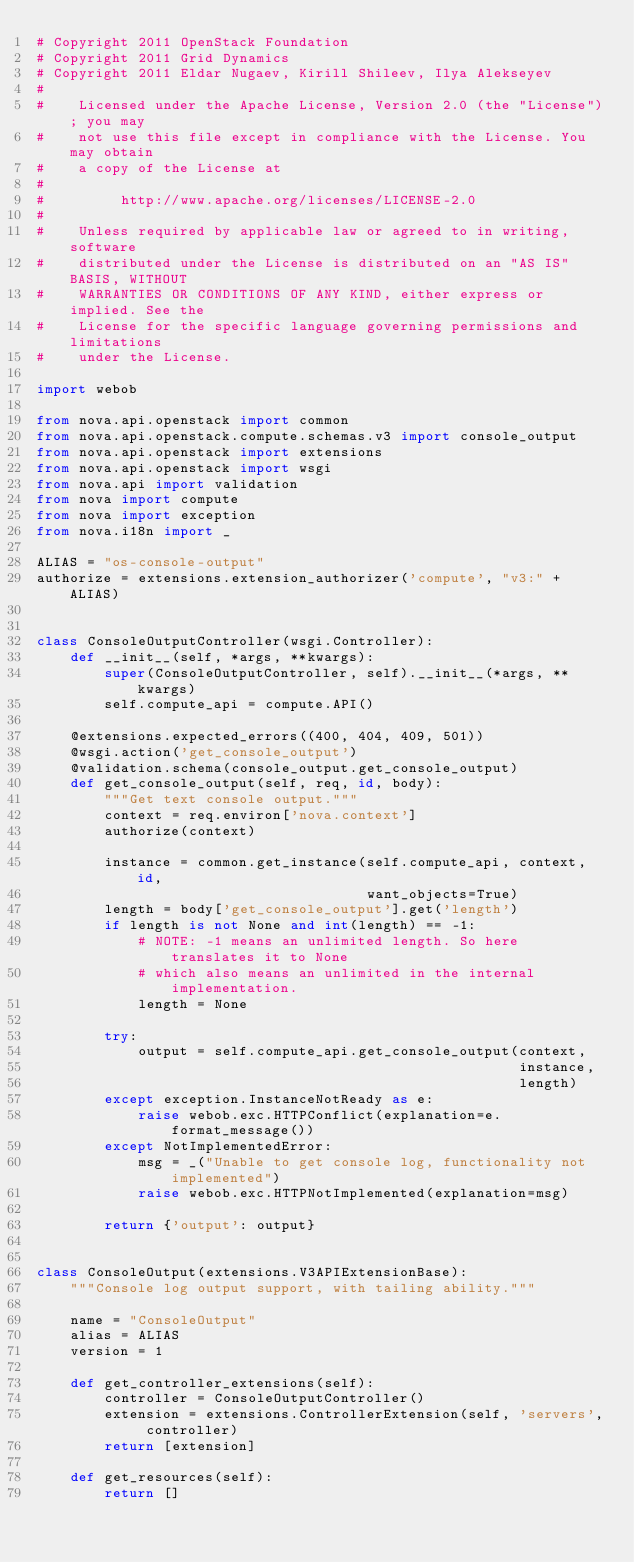<code> <loc_0><loc_0><loc_500><loc_500><_Python_># Copyright 2011 OpenStack Foundation
# Copyright 2011 Grid Dynamics
# Copyright 2011 Eldar Nugaev, Kirill Shileev, Ilya Alekseyev
#
#    Licensed under the Apache License, Version 2.0 (the "License"); you may
#    not use this file except in compliance with the License. You may obtain
#    a copy of the License at
#
#         http://www.apache.org/licenses/LICENSE-2.0
#
#    Unless required by applicable law or agreed to in writing, software
#    distributed under the License is distributed on an "AS IS" BASIS, WITHOUT
#    WARRANTIES OR CONDITIONS OF ANY KIND, either express or implied. See the
#    License for the specific language governing permissions and limitations
#    under the License.

import webob

from nova.api.openstack import common
from nova.api.openstack.compute.schemas.v3 import console_output
from nova.api.openstack import extensions
from nova.api.openstack import wsgi
from nova.api import validation
from nova import compute
from nova import exception
from nova.i18n import _

ALIAS = "os-console-output"
authorize = extensions.extension_authorizer('compute', "v3:" + ALIAS)


class ConsoleOutputController(wsgi.Controller):
    def __init__(self, *args, **kwargs):
        super(ConsoleOutputController, self).__init__(*args, **kwargs)
        self.compute_api = compute.API()

    @extensions.expected_errors((400, 404, 409, 501))
    @wsgi.action('get_console_output')
    @validation.schema(console_output.get_console_output)
    def get_console_output(self, req, id, body):
        """Get text console output."""
        context = req.environ['nova.context']
        authorize(context)

        instance = common.get_instance(self.compute_api, context, id,
                                       want_objects=True)
        length = body['get_console_output'].get('length')
        if length is not None and int(length) == -1:
            # NOTE: -1 means an unlimited length. So here translates it to None
            # which also means an unlimited in the internal implementation.
            length = None

        try:
            output = self.compute_api.get_console_output(context,
                                                         instance,
                                                         length)
        except exception.InstanceNotReady as e:
            raise webob.exc.HTTPConflict(explanation=e.format_message())
        except NotImplementedError:
            msg = _("Unable to get console log, functionality not implemented")
            raise webob.exc.HTTPNotImplemented(explanation=msg)

        return {'output': output}


class ConsoleOutput(extensions.V3APIExtensionBase):
    """Console log output support, with tailing ability."""

    name = "ConsoleOutput"
    alias = ALIAS
    version = 1

    def get_controller_extensions(self):
        controller = ConsoleOutputController()
        extension = extensions.ControllerExtension(self, 'servers', controller)
        return [extension]

    def get_resources(self):
        return []
</code> 